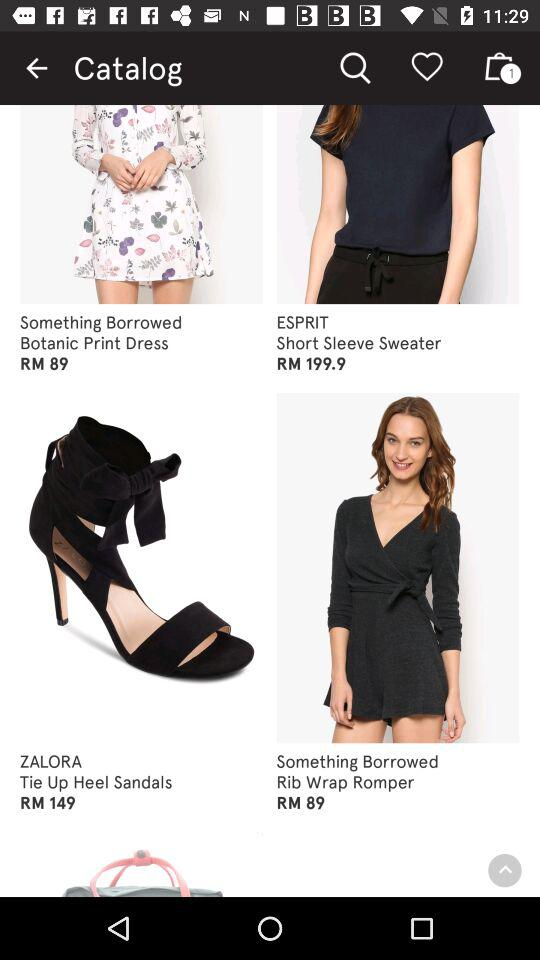What is the price of ESPRIT Short Sleeve Sweater? The price of ESPRIT Short Sleeve Sweater is RM 199.9. 